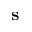<formula> <loc_0><loc_0><loc_500><loc_500>s</formula> 